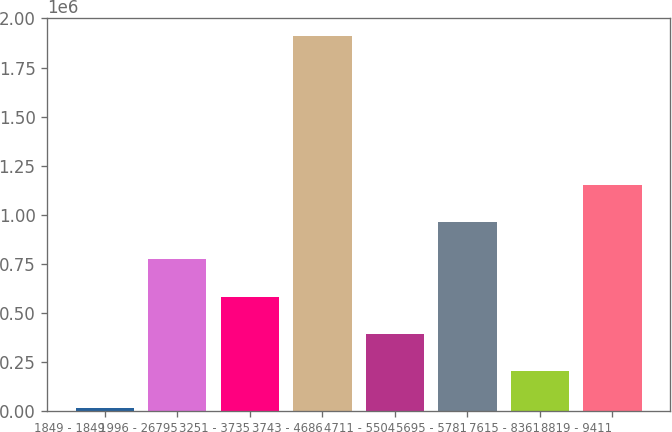<chart> <loc_0><loc_0><loc_500><loc_500><bar_chart><fcel>1849 - 1849<fcel>1996 - 26795<fcel>3251 - 3735<fcel>3743 - 4686<fcel>4711 - 5504<fcel>5695 - 5781<fcel>7615 - 8361<fcel>8819 - 9411<nl><fcel>12000<fcel>770827<fcel>581120<fcel>1.90907e+06<fcel>391414<fcel>960534<fcel>201707<fcel>1.15024e+06<nl></chart> 